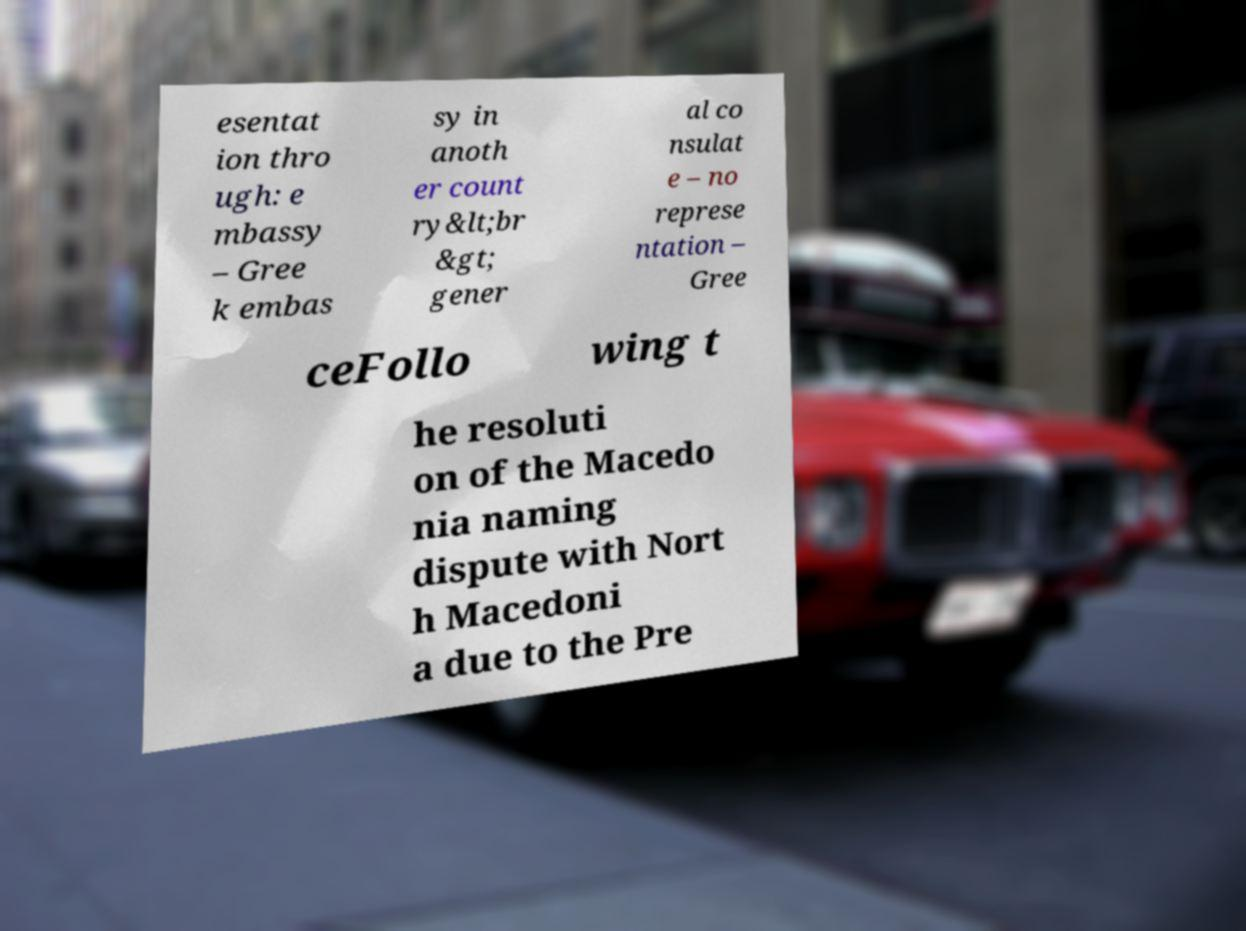There's text embedded in this image that I need extracted. Can you transcribe it verbatim? esentat ion thro ugh: e mbassy – Gree k embas sy in anoth er count ry&lt;br &gt; gener al co nsulat e – no represe ntation – Gree ceFollo wing t he resoluti on of the Macedo nia naming dispute with Nort h Macedoni a due to the Pre 